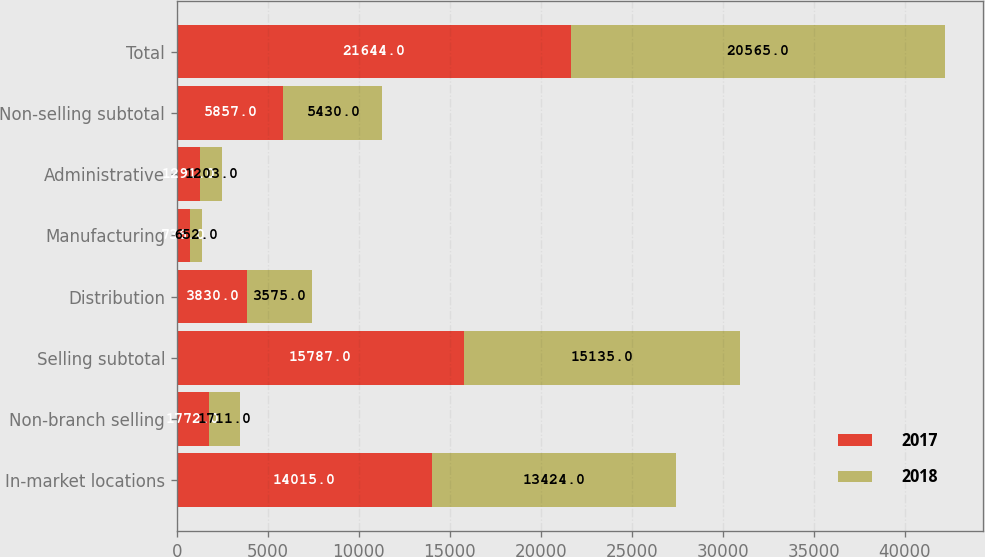<chart> <loc_0><loc_0><loc_500><loc_500><stacked_bar_chart><ecel><fcel>In-market locations<fcel>Non-branch selling<fcel>Selling subtotal<fcel>Distribution<fcel>Manufacturing<fcel>Administrative<fcel>Non-selling subtotal<fcel>Total<nl><fcel>2017<fcel>14015<fcel>1772<fcel>15787<fcel>3830<fcel>736<fcel>1291<fcel>5857<fcel>21644<nl><fcel>2018<fcel>13424<fcel>1711<fcel>15135<fcel>3575<fcel>652<fcel>1203<fcel>5430<fcel>20565<nl></chart> 